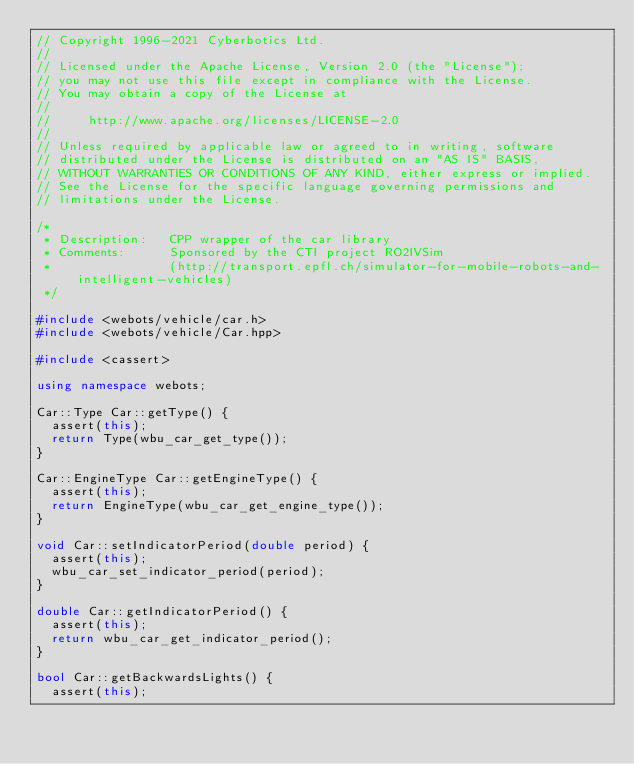<code> <loc_0><loc_0><loc_500><loc_500><_C++_>// Copyright 1996-2021 Cyberbotics Ltd.
//
// Licensed under the Apache License, Version 2.0 (the "License");
// you may not use this file except in compliance with the License.
// You may obtain a copy of the License at
//
//     http://www.apache.org/licenses/LICENSE-2.0
//
// Unless required by applicable law or agreed to in writing, software
// distributed under the License is distributed on an "AS IS" BASIS,
// WITHOUT WARRANTIES OR CONDITIONS OF ANY KIND, either express or implied.
// See the License for the specific language governing permissions and
// limitations under the License.

/*
 * Description:   CPP wrapper of the car library
 * Comments:      Sponsored by the CTI project RO2IVSim
 *                (http://transport.epfl.ch/simulator-for-mobile-robots-and-intelligent-vehicles)
 */

#include <webots/vehicle/car.h>
#include <webots/vehicle/Car.hpp>

#include <cassert>

using namespace webots;

Car::Type Car::getType() {
  assert(this);
  return Type(wbu_car_get_type());
}

Car::EngineType Car::getEngineType() {
  assert(this);
  return EngineType(wbu_car_get_engine_type());
}

void Car::setIndicatorPeriod(double period) {
  assert(this);
  wbu_car_set_indicator_period(period);
}

double Car::getIndicatorPeriod() {
  assert(this);
  return wbu_car_get_indicator_period();
}

bool Car::getBackwardsLights() {
  assert(this);</code> 